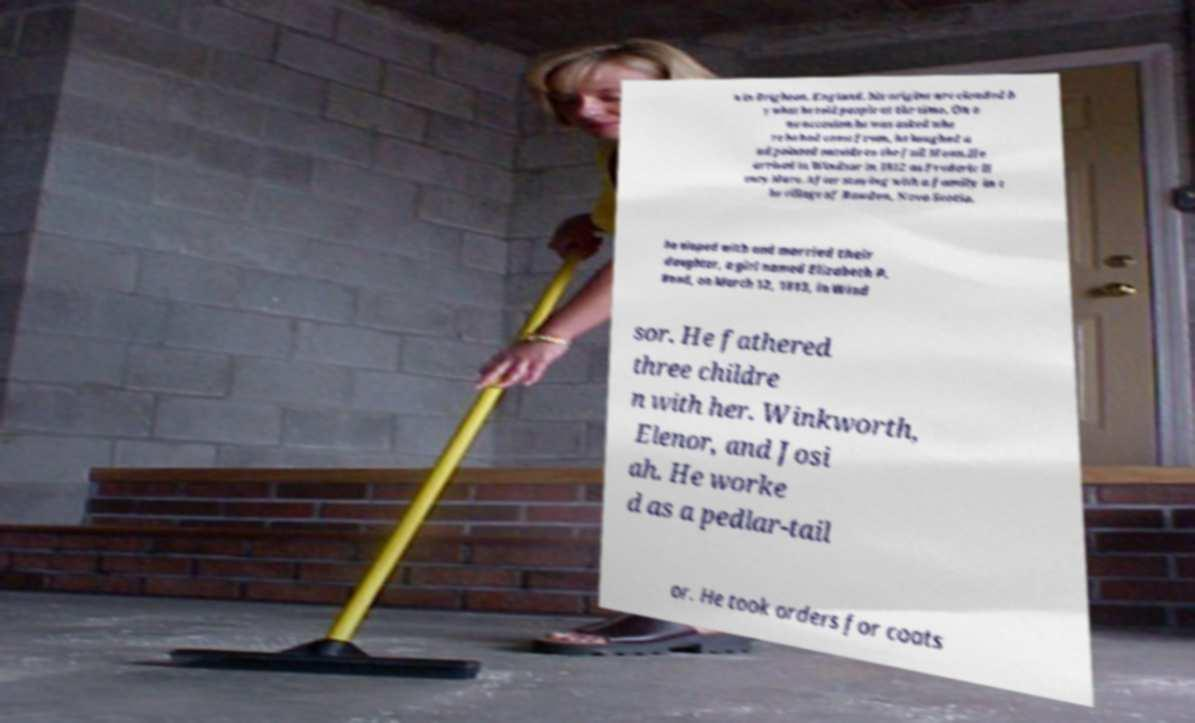There's text embedded in this image that I need extracted. Can you transcribe it verbatim? n in Brighton, England, his origins are clouded b y what he told people at the time. On o ne occasion he was asked whe re he had come from, he laughed a nd pointed outside to the full Moon.He arrived in Windsor in 1812 as Frederic H enry More. After staying with a family in t he village of Rawdon, Nova Scotia, he eloped with and married their daughter, a girl named Elizabeth P. Bond, on March 12, 1813, in Wind sor. He fathered three childre n with her. Winkworth, Elenor, and Josi ah. He worke d as a pedlar-tail or. He took orders for coats 